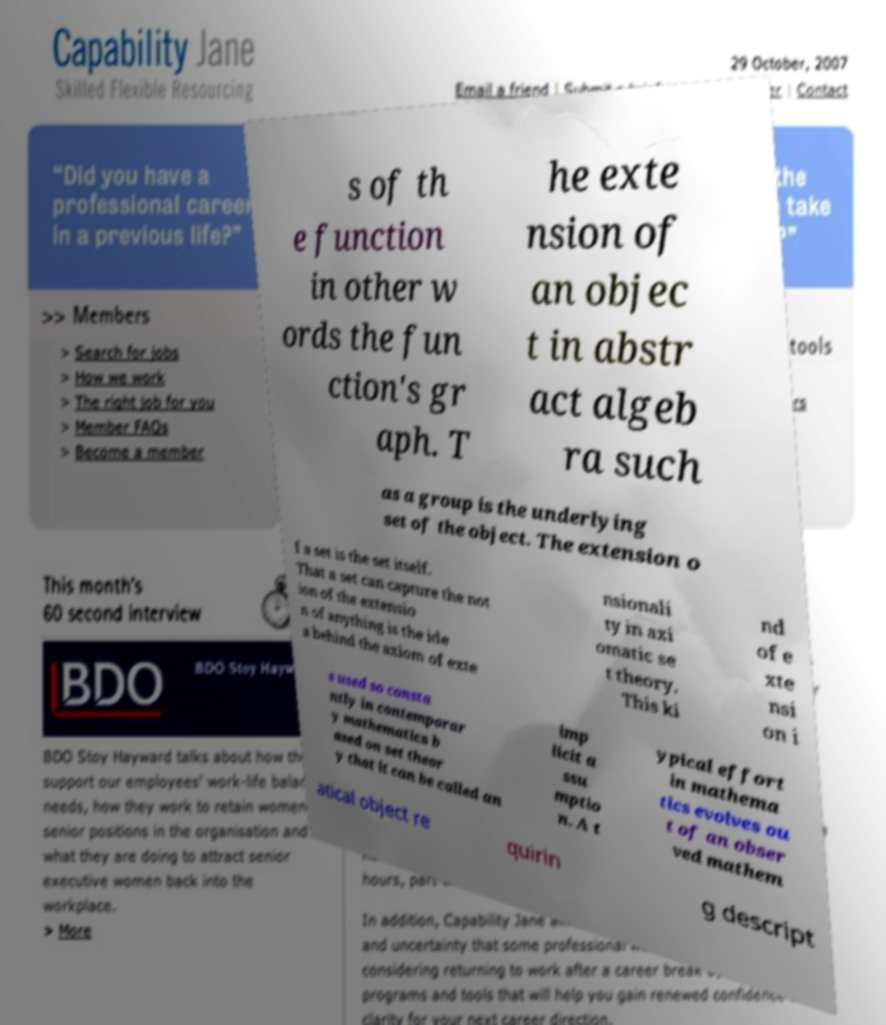What messages or text are displayed in this image? I need them in a readable, typed format. s of th e function in other w ords the fun ction's gr aph. T he exte nsion of an objec t in abstr act algeb ra such as a group is the underlying set of the object. The extension o f a set is the set itself. That a set can capture the not ion of the extensio n of anything is the ide a behind the axiom of exte nsionali ty in axi omatic se t theory. This ki nd of e xte nsi on i s used so consta ntly in contemporar y mathematics b ased on set theor y that it can be called an imp licit a ssu mptio n. A t ypical effort in mathema tics evolves ou t of an obser ved mathem atical object re quirin g descript 